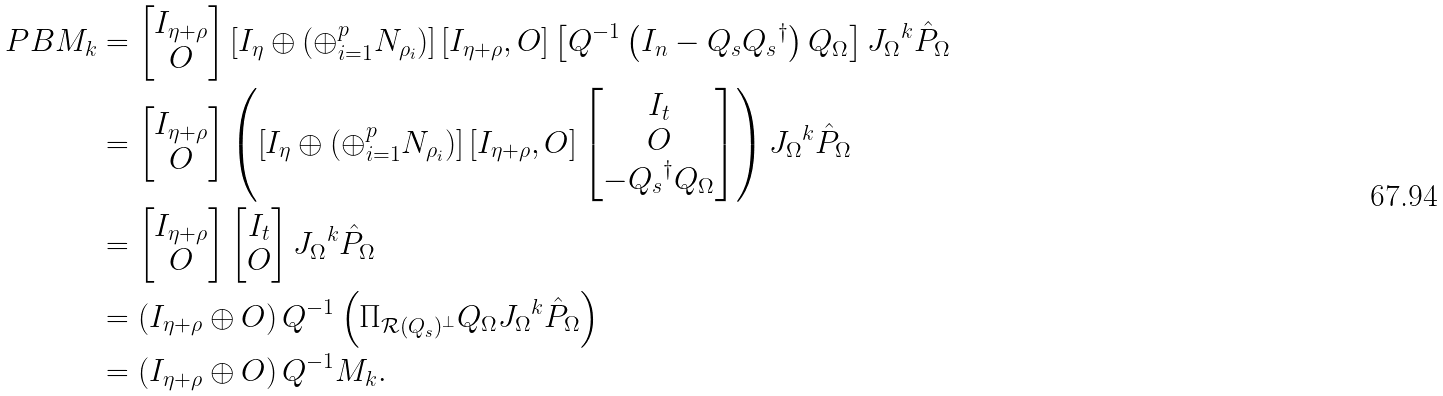Convert formula to latex. <formula><loc_0><loc_0><loc_500><loc_500>P B M _ { k } & = \begin{bmatrix} I _ { \eta + \rho } \\ O \end{bmatrix} \left [ I _ { \eta } \oplus \left ( \oplus _ { i = 1 } ^ { p } N _ { \rho _ { i } } \right ) \right ] \left [ I _ { \eta + \rho } , O \right ] \left [ Q ^ { - 1 } \left ( I _ { n } - Q _ { s } { Q _ { s } } ^ { \dag } \right ) Q _ { \Omega } \right ] { J _ { \Omega } } ^ { k } \hat { P } _ { \Omega } \\ & = \begin{bmatrix} I _ { \eta + \rho } \\ O \end{bmatrix} \left ( \left [ I _ { \eta } \oplus \left ( \oplus _ { i = 1 } ^ { p } N _ { \rho _ { i } } \right ) \right ] \left [ I _ { \eta + \rho } , O \right ] \begin{bmatrix} I _ { t } \\ O \\ - { Q _ { s } } ^ { \dag } Q _ { \Omega } \end{bmatrix} \right ) { J _ { \Omega } } ^ { k } \hat { P } _ { \Omega } \\ & = \begin{bmatrix} I _ { \eta + \rho } \\ O \end{bmatrix} \begin{bmatrix} I _ { t } \\ O \end{bmatrix} { J _ { \Omega } } ^ { k } \hat { P } _ { \Omega } \\ & = \left ( I _ { \eta + \rho } \oplus O \right ) Q ^ { - 1 } \left ( \Pi _ { \mathcal { R } ( Q _ { s } ) ^ { \perp } } Q _ { \Omega } { J _ { \Omega } } ^ { k } \hat { P } _ { \Omega } \right ) \\ & = \left ( I _ { \eta + \rho } \oplus O \right ) Q ^ { - 1 } M _ { k } .</formula> 